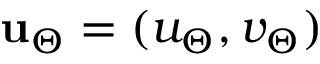Convert formula to latex. <formula><loc_0><loc_0><loc_500><loc_500>u _ { \Theta } = ( u _ { \Theta } , v _ { \Theta } )</formula> 